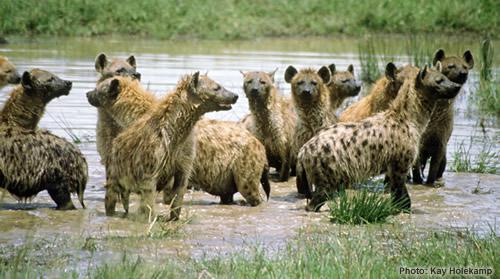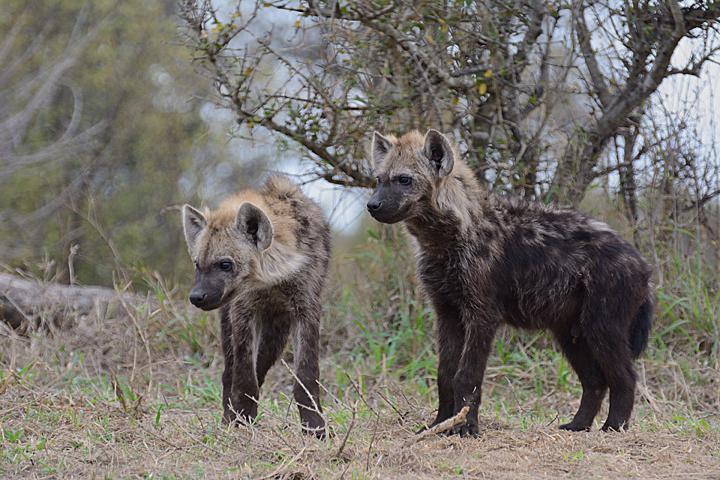The first image is the image on the left, the second image is the image on the right. Evaluate the accuracy of this statement regarding the images: "At least one of the images shows hyenas eating a carcass.". Is it true? Answer yes or no. No. The first image is the image on the left, the second image is the image on the right. For the images shown, is this caption "Some of the animals are eating their prey." true? Answer yes or no. No. 